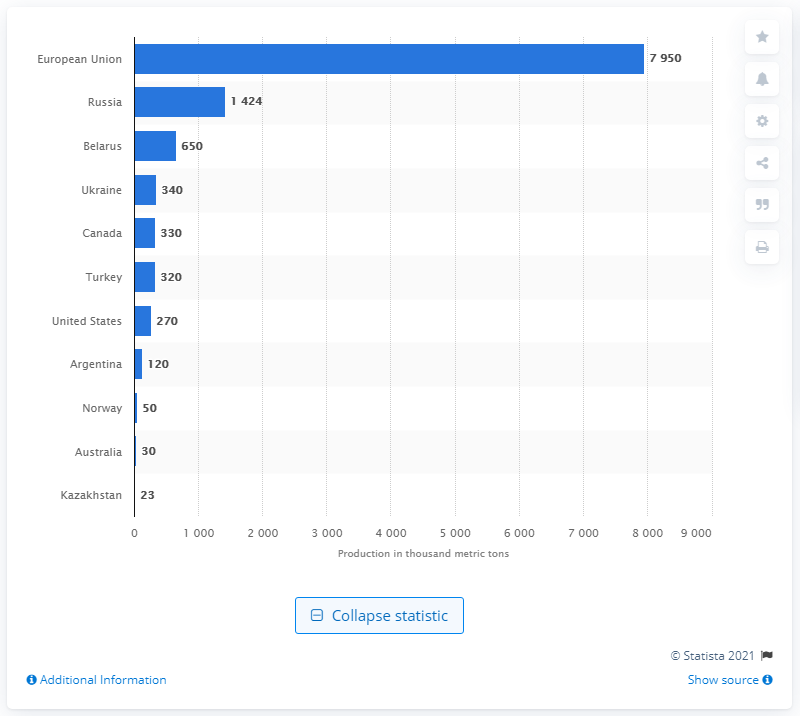Identify some key points in this picture. In the 2019/2020 crop year, Belarus was the country that produced the largest quantity of rye, with a total output of 650,000 metric tons. 